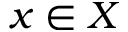<formula> <loc_0><loc_0><loc_500><loc_500>x \in X</formula> 